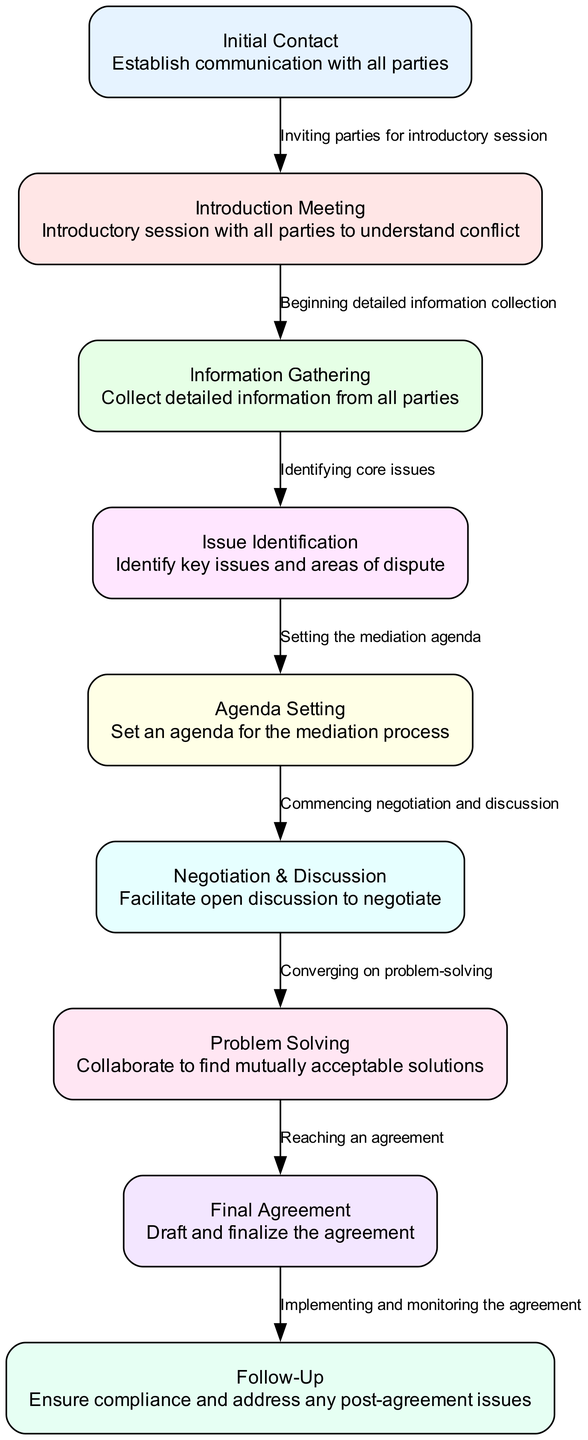What is the first step in the mediation process? The first step listed in the diagram is "Initial Contact," which involves establishing communication with all parties.
Answer: Initial Contact How many steps are there in the conflict resolution process? The diagram provides a total of 9 steps, as detailed in the flowchart.
Answer: 9 What is the purpose of the "Agenda Setting" step? "Agenda Setting" is meant to set an agenda for the mediation process, which organizes the topics that will be discussed during mediation.
Answer: Set an agenda Which step directly follows "Information Gathering"? The step that comes directly after "Information Gathering" in the flowchart is "Issue Identification."
Answer: Issue Identification What do the arrows between the steps represent? The arrows indicate the transitions from one step to the next, showing the flow of the mediation process.
Answer: Transitions What is the final step in the conflict resolution process? The last step highlighted in the diagram is "Follow-Up," which ensures compliance and addresses any post-agreement issues.
Answer: Follow-Up Identify two steps that involve collaboration. The steps "Problem Solving" and "Negotiation & Discussion" both involve collaboration among the parties to arrive at solutions and agreements.
Answer: Problem Solving, Negotiation & Discussion What is the relationship between "Final Agreement" and "Follow-Up"? The relationship is sequential; once the "Final Agreement" is reached, the process transitions to "Follow-Up," which involves monitoring the agreement's implementation.
Answer: Follow-Up How does "Negotiation & Discussion" relate to "Problem Solving"? "Negotiation & Discussion" is the step that leads directly into "Problem Solving," as it sets the stage for collaborative solution finding.
Answer: Leads to 